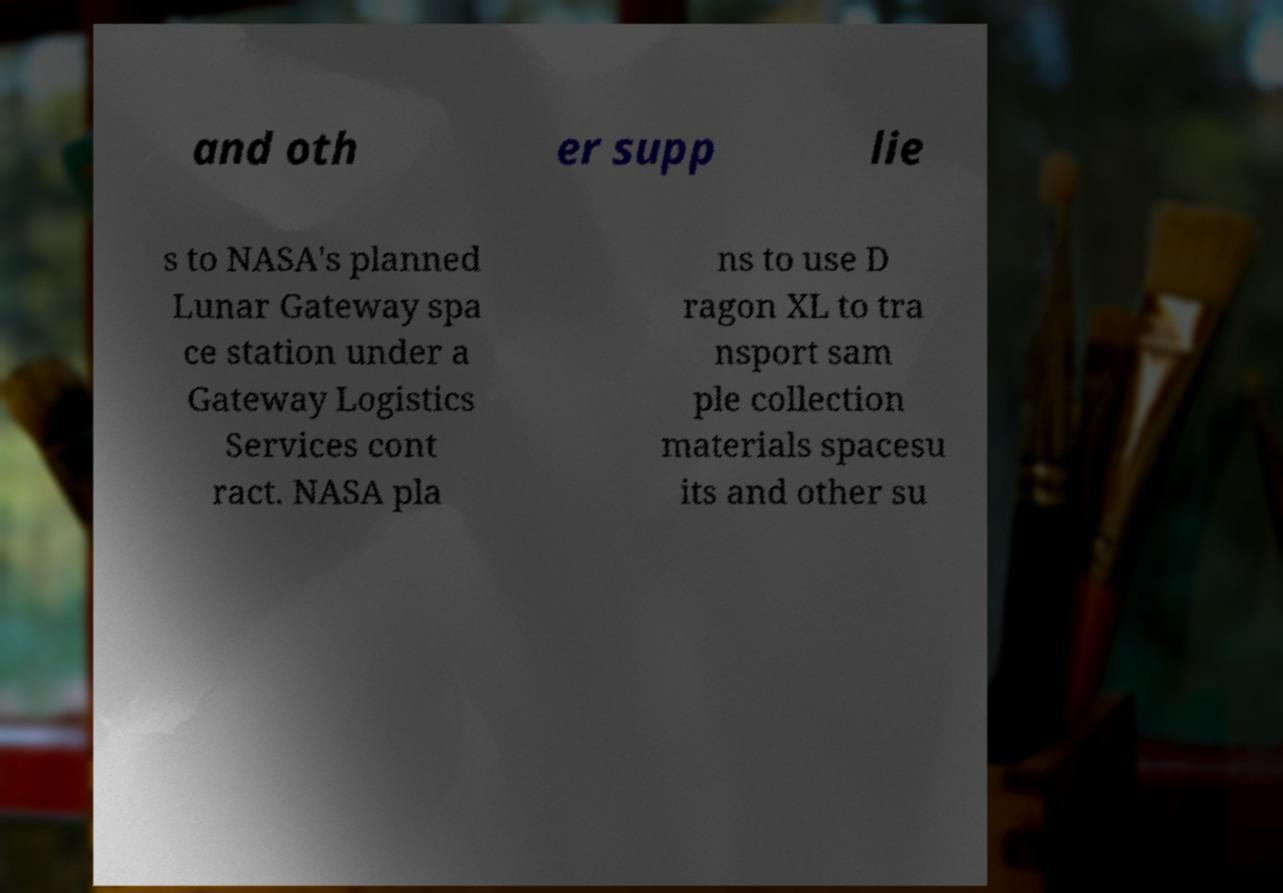Could you assist in decoding the text presented in this image and type it out clearly? and oth er supp lie s to NASA's planned Lunar Gateway spa ce station under a Gateway Logistics Services cont ract. NASA pla ns to use D ragon XL to tra nsport sam ple collection materials spacesu its and other su 